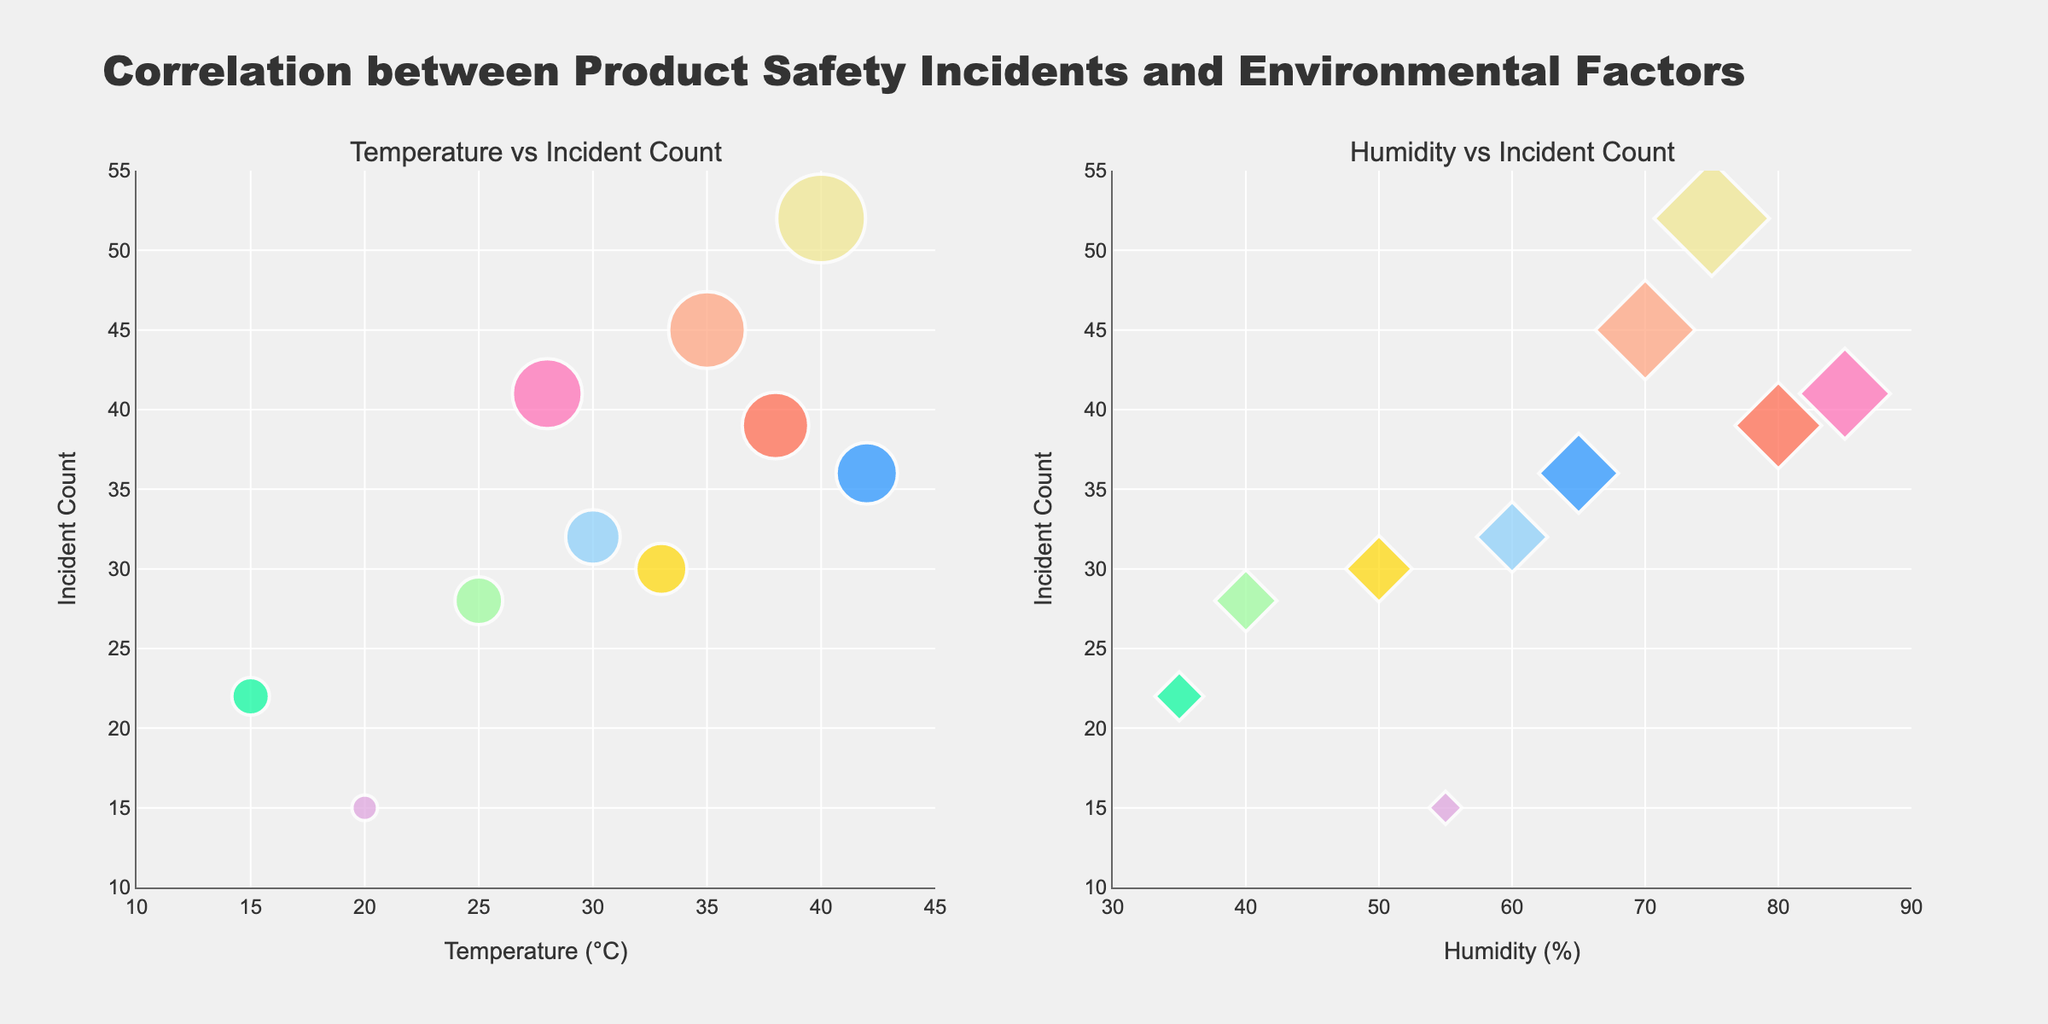what is the title of the figure? The title of the figure is usually displayed prominently at the top of the plot. In this case, the title provided is "Correlation between Product Safety Incidents and Environmental Factors".
Answer: Correlation between Product Safety Incidents and Environmental Factors How many data points are there in the Temperature vs Incident Count subplot? The number of data points corresponds to the number of markers in the plot. There are ten different products listed, so there should be ten data points in the subplot.
Answer: 10 Which product has the highest incident count in relation to temperature? By looking at the Temperature vs Incident Count subplot, locate the marker with the highest y-value (Incident Count). Here, the Power Strip has the highest incident count at a temperature of 40°C with an incident count of 52.
Answer: Power Strip Among the products listed, which one operates at the lowest temperature? Find the data point with the lowest x-value (Temperature). The Electric Blanket operates at the lowest temperature of 15°C.
Answer: Electric Blanket What are the incident counts for the Hair Dryer and the Power Strip? From the Temperature vs Incident subplot, identify the markers representing Hair Dryer and Power Strip. Their incident counts are 15 and 52 respectively.
Answer: 15 and 52 Do any products share the same incident count but have different environmental conditions? Check markers in both subplots to see if any y-values (Incident Count) repeat. The Portable Generator and the Electric Space Heater both have an incident count of 30 but operate under different conditions: Portable Generator at 33°C and 50% humidity, while Electric Space Heater operates at 25°C and 40% humidity.
Answer: Yes What is the average humidity percentage for all products? Average humidity is calculated by summing up all humidity values and dividing by the number of data points: (70+40+60+55+75+80+35+65+85+50)/10 = 61.5%.
Answer: 61.5% Which subplot indicates a higher concentration of incidents at the highest incident count range (above 40 incidents)? Look for the clusters of points with y-values above 40 in both subplots. The Temperature vs Incident subplot shows three data points (Power Strip, Lithium-ion Battery, Outdoor Gas Grill) above 40, while the Humidity vs Incident subplot shows similar three data points indicating a concentration in both subplots.
Answer: Both How is the incident count correlated to humidity based on the bubble size and position? Examine the distribution pattern and clustering of markers in the Humidity vs Incident subplot. Larger bubbles tend to appear towards higher humidity percentages (above 60%), suggesting a positive correlation where higher humidity relates to more incidents.
Answer: Positively correlated Which product appears to be the most outlier in terms of incident count in the Humidity vs Incident Count subplot, and why? Identify the product with the highest incident count and position in the Humidity vs Incident Count subplot. The Power Strip stands out with 52 incidents at 75% humidity, significantly higher than most other data points.
Answer: Power Strip 